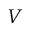<formula> <loc_0><loc_0><loc_500><loc_500>V</formula> 